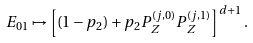<formula> <loc_0><loc_0><loc_500><loc_500>E _ { 0 1 } \mapsto \left [ ( 1 - p _ { 2 } ) + p _ { 2 } P _ { Z } ^ { ( j , 0 ) } P _ { Z } ^ { ( j , 1 ) } \right ] ^ { d + 1 } .</formula> 